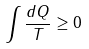Convert formula to latex. <formula><loc_0><loc_0><loc_500><loc_500>\int \frac { d Q } { T } \geq 0</formula> 